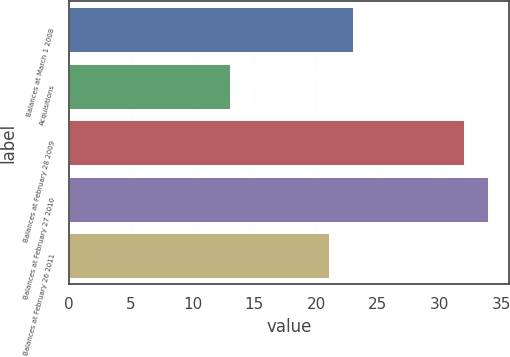Convert chart. <chart><loc_0><loc_0><loc_500><loc_500><bar_chart><fcel>Balances at March 1 2008<fcel>Acquisitions<fcel>Balances at February 28 2009<fcel>Balances at February 27 2010<fcel>Balances at February 26 2011<nl><fcel>23<fcel>13<fcel>32<fcel>33.9<fcel>21<nl></chart> 